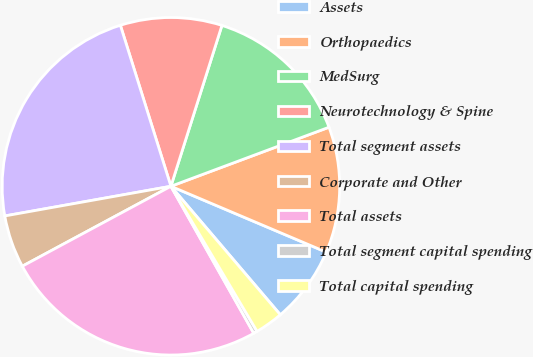Convert chart. <chart><loc_0><loc_0><loc_500><loc_500><pie_chart><fcel>Assets<fcel>Orthopaedics<fcel>MedSurg<fcel>Neurotechnology & Spine<fcel>Total segment assets<fcel>Corporate and Other<fcel>Total assets<fcel>Total segment capital spending<fcel>Total capital spending<nl><fcel>7.39%<fcel>12.07%<fcel>14.42%<fcel>9.73%<fcel>22.97%<fcel>5.04%<fcel>25.31%<fcel>0.36%<fcel>2.7%<nl></chart> 